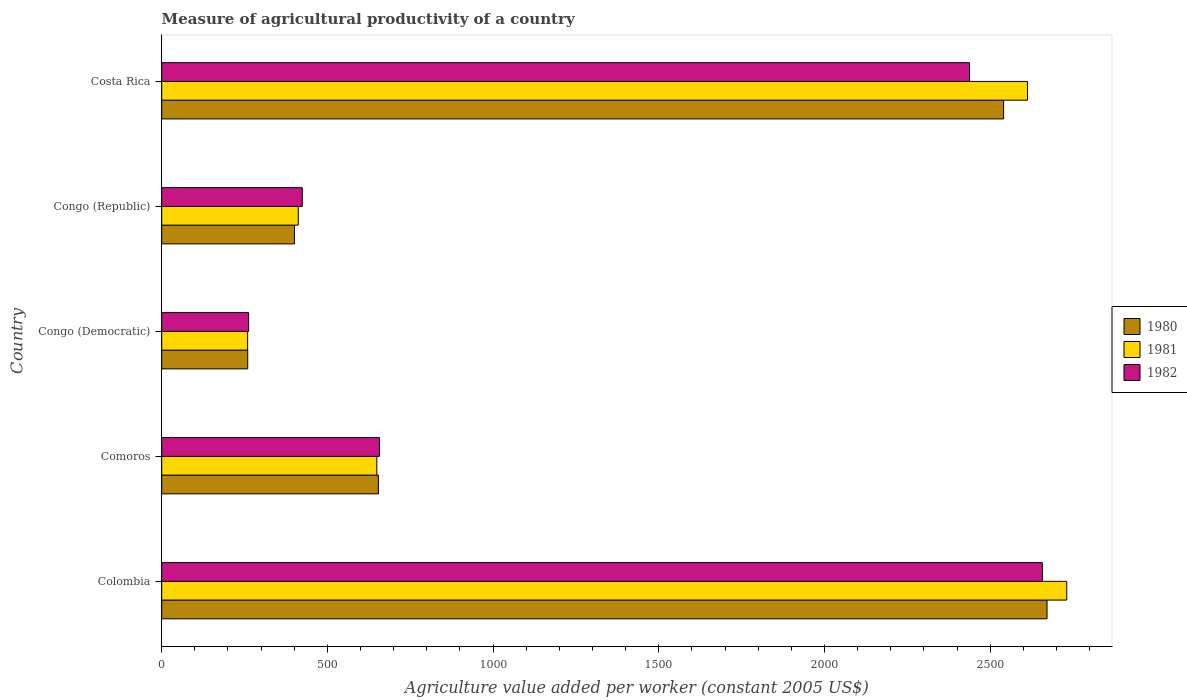How many different coloured bars are there?
Ensure brevity in your answer.  3. Are the number of bars per tick equal to the number of legend labels?
Offer a terse response. Yes. Are the number of bars on each tick of the Y-axis equal?
Your response must be concise. Yes. How many bars are there on the 1st tick from the top?
Your answer should be compact. 3. What is the label of the 2nd group of bars from the top?
Offer a terse response. Congo (Republic). In how many cases, is the number of bars for a given country not equal to the number of legend labels?
Make the answer very short. 0. What is the measure of agricultural productivity in 1982 in Comoros?
Provide a succinct answer. 657.19. Across all countries, what is the maximum measure of agricultural productivity in 1982?
Give a very brief answer. 2657.56. Across all countries, what is the minimum measure of agricultural productivity in 1981?
Make the answer very short. 259.31. In which country was the measure of agricultural productivity in 1980 maximum?
Provide a short and direct response. Colombia. In which country was the measure of agricultural productivity in 1982 minimum?
Keep it short and to the point. Congo (Democratic). What is the total measure of agricultural productivity in 1981 in the graph?
Offer a very short reply. 6664.21. What is the difference between the measure of agricultural productivity in 1982 in Congo (Democratic) and that in Costa Rica?
Ensure brevity in your answer.  -2175.37. What is the difference between the measure of agricultural productivity in 1981 in Comoros and the measure of agricultural productivity in 1980 in Congo (Republic)?
Offer a terse response. 248.5. What is the average measure of agricultural productivity in 1982 per country?
Offer a terse response. 1287.78. What is the difference between the measure of agricultural productivity in 1982 and measure of agricultural productivity in 1981 in Colombia?
Give a very brief answer. -73.46. What is the ratio of the measure of agricultural productivity in 1980 in Congo (Republic) to that in Costa Rica?
Ensure brevity in your answer.  0.16. Is the measure of agricultural productivity in 1980 in Congo (Democratic) less than that in Costa Rica?
Give a very brief answer. Yes. What is the difference between the highest and the second highest measure of agricultural productivity in 1982?
Offer a very short reply. 219.89. What is the difference between the highest and the lowest measure of agricultural productivity in 1981?
Make the answer very short. 2471.71. What does the 2nd bar from the bottom in Comoros represents?
Provide a short and direct response. 1981. Is it the case that in every country, the sum of the measure of agricultural productivity in 1981 and measure of agricultural productivity in 1982 is greater than the measure of agricultural productivity in 1980?
Your answer should be compact. Yes. What is the difference between two consecutive major ticks on the X-axis?
Your answer should be compact. 500. Are the values on the major ticks of X-axis written in scientific E-notation?
Your answer should be very brief. No. How are the legend labels stacked?
Keep it short and to the point. Vertical. What is the title of the graph?
Offer a terse response. Measure of agricultural productivity of a country. Does "1963" appear as one of the legend labels in the graph?
Your answer should be compact. No. What is the label or title of the X-axis?
Your answer should be compact. Agriculture value added per worker (constant 2005 US$). What is the Agriculture value added per worker (constant 2005 US$) in 1980 in Colombia?
Make the answer very short. 2671.6. What is the Agriculture value added per worker (constant 2005 US$) of 1981 in Colombia?
Provide a short and direct response. 2731.02. What is the Agriculture value added per worker (constant 2005 US$) of 1982 in Colombia?
Offer a very short reply. 2657.56. What is the Agriculture value added per worker (constant 2005 US$) in 1980 in Comoros?
Your answer should be very brief. 653.86. What is the Agriculture value added per worker (constant 2005 US$) of 1981 in Comoros?
Keep it short and to the point. 649.11. What is the Agriculture value added per worker (constant 2005 US$) of 1982 in Comoros?
Provide a succinct answer. 657.19. What is the Agriculture value added per worker (constant 2005 US$) of 1980 in Congo (Democratic)?
Your answer should be compact. 259.6. What is the Agriculture value added per worker (constant 2005 US$) in 1981 in Congo (Democratic)?
Ensure brevity in your answer.  259.31. What is the Agriculture value added per worker (constant 2005 US$) of 1982 in Congo (Democratic)?
Provide a short and direct response. 262.3. What is the Agriculture value added per worker (constant 2005 US$) in 1980 in Congo (Republic)?
Make the answer very short. 400.61. What is the Agriculture value added per worker (constant 2005 US$) in 1981 in Congo (Republic)?
Your answer should be very brief. 412. What is the Agriculture value added per worker (constant 2005 US$) of 1982 in Congo (Republic)?
Offer a very short reply. 424.18. What is the Agriculture value added per worker (constant 2005 US$) of 1980 in Costa Rica?
Offer a very short reply. 2540.48. What is the Agriculture value added per worker (constant 2005 US$) of 1981 in Costa Rica?
Give a very brief answer. 2612.77. What is the Agriculture value added per worker (constant 2005 US$) in 1982 in Costa Rica?
Your response must be concise. 2437.67. Across all countries, what is the maximum Agriculture value added per worker (constant 2005 US$) in 1980?
Give a very brief answer. 2671.6. Across all countries, what is the maximum Agriculture value added per worker (constant 2005 US$) in 1981?
Ensure brevity in your answer.  2731.02. Across all countries, what is the maximum Agriculture value added per worker (constant 2005 US$) of 1982?
Make the answer very short. 2657.56. Across all countries, what is the minimum Agriculture value added per worker (constant 2005 US$) in 1980?
Your response must be concise. 259.6. Across all countries, what is the minimum Agriculture value added per worker (constant 2005 US$) in 1981?
Keep it short and to the point. 259.31. Across all countries, what is the minimum Agriculture value added per worker (constant 2005 US$) in 1982?
Ensure brevity in your answer.  262.3. What is the total Agriculture value added per worker (constant 2005 US$) in 1980 in the graph?
Ensure brevity in your answer.  6526.15. What is the total Agriculture value added per worker (constant 2005 US$) of 1981 in the graph?
Offer a very short reply. 6664.21. What is the total Agriculture value added per worker (constant 2005 US$) of 1982 in the graph?
Your answer should be compact. 6438.9. What is the difference between the Agriculture value added per worker (constant 2005 US$) in 1980 in Colombia and that in Comoros?
Offer a very short reply. 2017.73. What is the difference between the Agriculture value added per worker (constant 2005 US$) in 1981 in Colombia and that in Comoros?
Ensure brevity in your answer.  2081.9. What is the difference between the Agriculture value added per worker (constant 2005 US$) in 1982 in Colombia and that in Comoros?
Ensure brevity in your answer.  2000.38. What is the difference between the Agriculture value added per worker (constant 2005 US$) in 1980 in Colombia and that in Congo (Democratic)?
Make the answer very short. 2412. What is the difference between the Agriculture value added per worker (constant 2005 US$) of 1981 in Colombia and that in Congo (Democratic)?
Your answer should be compact. 2471.71. What is the difference between the Agriculture value added per worker (constant 2005 US$) of 1982 in Colombia and that in Congo (Democratic)?
Make the answer very short. 2395.26. What is the difference between the Agriculture value added per worker (constant 2005 US$) in 1980 in Colombia and that in Congo (Republic)?
Your answer should be very brief. 2270.98. What is the difference between the Agriculture value added per worker (constant 2005 US$) in 1981 in Colombia and that in Congo (Republic)?
Provide a short and direct response. 2319.02. What is the difference between the Agriculture value added per worker (constant 2005 US$) in 1982 in Colombia and that in Congo (Republic)?
Make the answer very short. 2233.39. What is the difference between the Agriculture value added per worker (constant 2005 US$) of 1980 in Colombia and that in Costa Rica?
Give a very brief answer. 131.12. What is the difference between the Agriculture value added per worker (constant 2005 US$) in 1981 in Colombia and that in Costa Rica?
Provide a short and direct response. 118.25. What is the difference between the Agriculture value added per worker (constant 2005 US$) of 1982 in Colombia and that in Costa Rica?
Provide a short and direct response. 219.89. What is the difference between the Agriculture value added per worker (constant 2005 US$) of 1980 in Comoros and that in Congo (Democratic)?
Offer a very short reply. 394.26. What is the difference between the Agriculture value added per worker (constant 2005 US$) of 1981 in Comoros and that in Congo (Democratic)?
Offer a terse response. 389.81. What is the difference between the Agriculture value added per worker (constant 2005 US$) in 1982 in Comoros and that in Congo (Democratic)?
Give a very brief answer. 394.89. What is the difference between the Agriculture value added per worker (constant 2005 US$) of 1980 in Comoros and that in Congo (Republic)?
Your answer should be compact. 253.25. What is the difference between the Agriculture value added per worker (constant 2005 US$) in 1981 in Comoros and that in Congo (Republic)?
Ensure brevity in your answer.  237.12. What is the difference between the Agriculture value added per worker (constant 2005 US$) of 1982 in Comoros and that in Congo (Republic)?
Your answer should be compact. 233.01. What is the difference between the Agriculture value added per worker (constant 2005 US$) in 1980 in Comoros and that in Costa Rica?
Provide a succinct answer. -1886.62. What is the difference between the Agriculture value added per worker (constant 2005 US$) of 1981 in Comoros and that in Costa Rica?
Provide a short and direct response. -1963.65. What is the difference between the Agriculture value added per worker (constant 2005 US$) in 1982 in Comoros and that in Costa Rica?
Your answer should be compact. -1780.48. What is the difference between the Agriculture value added per worker (constant 2005 US$) of 1980 in Congo (Democratic) and that in Congo (Republic)?
Make the answer very short. -141.01. What is the difference between the Agriculture value added per worker (constant 2005 US$) of 1981 in Congo (Democratic) and that in Congo (Republic)?
Provide a succinct answer. -152.69. What is the difference between the Agriculture value added per worker (constant 2005 US$) of 1982 in Congo (Democratic) and that in Congo (Republic)?
Provide a short and direct response. -161.87. What is the difference between the Agriculture value added per worker (constant 2005 US$) of 1980 in Congo (Democratic) and that in Costa Rica?
Ensure brevity in your answer.  -2280.88. What is the difference between the Agriculture value added per worker (constant 2005 US$) of 1981 in Congo (Democratic) and that in Costa Rica?
Provide a succinct answer. -2353.46. What is the difference between the Agriculture value added per worker (constant 2005 US$) in 1982 in Congo (Democratic) and that in Costa Rica?
Your answer should be compact. -2175.37. What is the difference between the Agriculture value added per worker (constant 2005 US$) of 1980 in Congo (Republic) and that in Costa Rica?
Provide a short and direct response. -2139.87. What is the difference between the Agriculture value added per worker (constant 2005 US$) of 1981 in Congo (Republic) and that in Costa Rica?
Your answer should be compact. -2200.77. What is the difference between the Agriculture value added per worker (constant 2005 US$) of 1982 in Congo (Republic) and that in Costa Rica?
Offer a very short reply. -2013.5. What is the difference between the Agriculture value added per worker (constant 2005 US$) of 1980 in Colombia and the Agriculture value added per worker (constant 2005 US$) of 1981 in Comoros?
Ensure brevity in your answer.  2022.48. What is the difference between the Agriculture value added per worker (constant 2005 US$) in 1980 in Colombia and the Agriculture value added per worker (constant 2005 US$) in 1982 in Comoros?
Provide a short and direct response. 2014.41. What is the difference between the Agriculture value added per worker (constant 2005 US$) of 1981 in Colombia and the Agriculture value added per worker (constant 2005 US$) of 1982 in Comoros?
Give a very brief answer. 2073.83. What is the difference between the Agriculture value added per worker (constant 2005 US$) in 1980 in Colombia and the Agriculture value added per worker (constant 2005 US$) in 1981 in Congo (Democratic)?
Provide a succinct answer. 2412.29. What is the difference between the Agriculture value added per worker (constant 2005 US$) in 1980 in Colombia and the Agriculture value added per worker (constant 2005 US$) in 1982 in Congo (Democratic)?
Ensure brevity in your answer.  2409.29. What is the difference between the Agriculture value added per worker (constant 2005 US$) in 1981 in Colombia and the Agriculture value added per worker (constant 2005 US$) in 1982 in Congo (Democratic)?
Provide a short and direct response. 2468.72. What is the difference between the Agriculture value added per worker (constant 2005 US$) of 1980 in Colombia and the Agriculture value added per worker (constant 2005 US$) of 1981 in Congo (Republic)?
Provide a short and direct response. 2259.6. What is the difference between the Agriculture value added per worker (constant 2005 US$) in 1980 in Colombia and the Agriculture value added per worker (constant 2005 US$) in 1982 in Congo (Republic)?
Keep it short and to the point. 2247.42. What is the difference between the Agriculture value added per worker (constant 2005 US$) in 1981 in Colombia and the Agriculture value added per worker (constant 2005 US$) in 1982 in Congo (Republic)?
Offer a very short reply. 2306.84. What is the difference between the Agriculture value added per worker (constant 2005 US$) in 1980 in Colombia and the Agriculture value added per worker (constant 2005 US$) in 1981 in Costa Rica?
Offer a terse response. 58.83. What is the difference between the Agriculture value added per worker (constant 2005 US$) of 1980 in Colombia and the Agriculture value added per worker (constant 2005 US$) of 1982 in Costa Rica?
Your answer should be compact. 233.92. What is the difference between the Agriculture value added per worker (constant 2005 US$) in 1981 in Colombia and the Agriculture value added per worker (constant 2005 US$) in 1982 in Costa Rica?
Offer a very short reply. 293.35. What is the difference between the Agriculture value added per worker (constant 2005 US$) in 1980 in Comoros and the Agriculture value added per worker (constant 2005 US$) in 1981 in Congo (Democratic)?
Keep it short and to the point. 394.55. What is the difference between the Agriculture value added per worker (constant 2005 US$) in 1980 in Comoros and the Agriculture value added per worker (constant 2005 US$) in 1982 in Congo (Democratic)?
Your answer should be very brief. 391.56. What is the difference between the Agriculture value added per worker (constant 2005 US$) of 1981 in Comoros and the Agriculture value added per worker (constant 2005 US$) of 1982 in Congo (Democratic)?
Ensure brevity in your answer.  386.81. What is the difference between the Agriculture value added per worker (constant 2005 US$) in 1980 in Comoros and the Agriculture value added per worker (constant 2005 US$) in 1981 in Congo (Republic)?
Keep it short and to the point. 241.86. What is the difference between the Agriculture value added per worker (constant 2005 US$) in 1980 in Comoros and the Agriculture value added per worker (constant 2005 US$) in 1982 in Congo (Republic)?
Your answer should be compact. 229.69. What is the difference between the Agriculture value added per worker (constant 2005 US$) in 1981 in Comoros and the Agriculture value added per worker (constant 2005 US$) in 1982 in Congo (Republic)?
Provide a succinct answer. 224.94. What is the difference between the Agriculture value added per worker (constant 2005 US$) in 1980 in Comoros and the Agriculture value added per worker (constant 2005 US$) in 1981 in Costa Rica?
Your answer should be compact. -1958.91. What is the difference between the Agriculture value added per worker (constant 2005 US$) of 1980 in Comoros and the Agriculture value added per worker (constant 2005 US$) of 1982 in Costa Rica?
Your response must be concise. -1783.81. What is the difference between the Agriculture value added per worker (constant 2005 US$) of 1981 in Comoros and the Agriculture value added per worker (constant 2005 US$) of 1982 in Costa Rica?
Make the answer very short. -1788.56. What is the difference between the Agriculture value added per worker (constant 2005 US$) in 1980 in Congo (Democratic) and the Agriculture value added per worker (constant 2005 US$) in 1981 in Congo (Republic)?
Keep it short and to the point. -152.4. What is the difference between the Agriculture value added per worker (constant 2005 US$) of 1980 in Congo (Democratic) and the Agriculture value added per worker (constant 2005 US$) of 1982 in Congo (Republic)?
Offer a terse response. -164.58. What is the difference between the Agriculture value added per worker (constant 2005 US$) of 1981 in Congo (Democratic) and the Agriculture value added per worker (constant 2005 US$) of 1982 in Congo (Republic)?
Offer a very short reply. -164.87. What is the difference between the Agriculture value added per worker (constant 2005 US$) of 1980 in Congo (Democratic) and the Agriculture value added per worker (constant 2005 US$) of 1981 in Costa Rica?
Keep it short and to the point. -2353.17. What is the difference between the Agriculture value added per worker (constant 2005 US$) of 1980 in Congo (Democratic) and the Agriculture value added per worker (constant 2005 US$) of 1982 in Costa Rica?
Your response must be concise. -2178.07. What is the difference between the Agriculture value added per worker (constant 2005 US$) in 1981 in Congo (Democratic) and the Agriculture value added per worker (constant 2005 US$) in 1982 in Costa Rica?
Your answer should be compact. -2178.36. What is the difference between the Agriculture value added per worker (constant 2005 US$) in 1980 in Congo (Republic) and the Agriculture value added per worker (constant 2005 US$) in 1981 in Costa Rica?
Keep it short and to the point. -2212.16. What is the difference between the Agriculture value added per worker (constant 2005 US$) of 1980 in Congo (Republic) and the Agriculture value added per worker (constant 2005 US$) of 1982 in Costa Rica?
Provide a succinct answer. -2037.06. What is the difference between the Agriculture value added per worker (constant 2005 US$) of 1981 in Congo (Republic) and the Agriculture value added per worker (constant 2005 US$) of 1982 in Costa Rica?
Provide a succinct answer. -2025.67. What is the average Agriculture value added per worker (constant 2005 US$) in 1980 per country?
Provide a succinct answer. 1305.23. What is the average Agriculture value added per worker (constant 2005 US$) in 1981 per country?
Your response must be concise. 1332.84. What is the average Agriculture value added per worker (constant 2005 US$) of 1982 per country?
Offer a very short reply. 1287.78. What is the difference between the Agriculture value added per worker (constant 2005 US$) of 1980 and Agriculture value added per worker (constant 2005 US$) of 1981 in Colombia?
Offer a very short reply. -59.42. What is the difference between the Agriculture value added per worker (constant 2005 US$) in 1980 and Agriculture value added per worker (constant 2005 US$) in 1982 in Colombia?
Keep it short and to the point. 14.03. What is the difference between the Agriculture value added per worker (constant 2005 US$) in 1981 and Agriculture value added per worker (constant 2005 US$) in 1982 in Colombia?
Offer a very short reply. 73.46. What is the difference between the Agriculture value added per worker (constant 2005 US$) in 1980 and Agriculture value added per worker (constant 2005 US$) in 1981 in Comoros?
Offer a terse response. 4.75. What is the difference between the Agriculture value added per worker (constant 2005 US$) of 1980 and Agriculture value added per worker (constant 2005 US$) of 1982 in Comoros?
Offer a terse response. -3.33. What is the difference between the Agriculture value added per worker (constant 2005 US$) of 1981 and Agriculture value added per worker (constant 2005 US$) of 1982 in Comoros?
Your answer should be very brief. -8.07. What is the difference between the Agriculture value added per worker (constant 2005 US$) of 1980 and Agriculture value added per worker (constant 2005 US$) of 1981 in Congo (Democratic)?
Your response must be concise. 0.29. What is the difference between the Agriculture value added per worker (constant 2005 US$) in 1980 and Agriculture value added per worker (constant 2005 US$) in 1982 in Congo (Democratic)?
Provide a succinct answer. -2.7. What is the difference between the Agriculture value added per worker (constant 2005 US$) of 1981 and Agriculture value added per worker (constant 2005 US$) of 1982 in Congo (Democratic)?
Give a very brief answer. -2.99. What is the difference between the Agriculture value added per worker (constant 2005 US$) of 1980 and Agriculture value added per worker (constant 2005 US$) of 1981 in Congo (Republic)?
Ensure brevity in your answer.  -11.38. What is the difference between the Agriculture value added per worker (constant 2005 US$) of 1980 and Agriculture value added per worker (constant 2005 US$) of 1982 in Congo (Republic)?
Offer a terse response. -23.56. What is the difference between the Agriculture value added per worker (constant 2005 US$) of 1981 and Agriculture value added per worker (constant 2005 US$) of 1982 in Congo (Republic)?
Give a very brief answer. -12.18. What is the difference between the Agriculture value added per worker (constant 2005 US$) in 1980 and Agriculture value added per worker (constant 2005 US$) in 1981 in Costa Rica?
Offer a very short reply. -72.29. What is the difference between the Agriculture value added per worker (constant 2005 US$) of 1980 and Agriculture value added per worker (constant 2005 US$) of 1982 in Costa Rica?
Your response must be concise. 102.81. What is the difference between the Agriculture value added per worker (constant 2005 US$) of 1981 and Agriculture value added per worker (constant 2005 US$) of 1982 in Costa Rica?
Keep it short and to the point. 175.1. What is the ratio of the Agriculture value added per worker (constant 2005 US$) in 1980 in Colombia to that in Comoros?
Your response must be concise. 4.09. What is the ratio of the Agriculture value added per worker (constant 2005 US$) in 1981 in Colombia to that in Comoros?
Keep it short and to the point. 4.21. What is the ratio of the Agriculture value added per worker (constant 2005 US$) in 1982 in Colombia to that in Comoros?
Provide a succinct answer. 4.04. What is the ratio of the Agriculture value added per worker (constant 2005 US$) in 1980 in Colombia to that in Congo (Democratic)?
Give a very brief answer. 10.29. What is the ratio of the Agriculture value added per worker (constant 2005 US$) of 1981 in Colombia to that in Congo (Democratic)?
Keep it short and to the point. 10.53. What is the ratio of the Agriculture value added per worker (constant 2005 US$) in 1982 in Colombia to that in Congo (Democratic)?
Offer a terse response. 10.13. What is the ratio of the Agriculture value added per worker (constant 2005 US$) in 1980 in Colombia to that in Congo (Republic)?
Your answer should be very brief. 6.67. What is the ratio of the Agriculture value added per worker (constant 2005 US$) of 1981 in Colombia to that in Congo (Republic)?
Your answer should be compact. 6.63. What is the ratio of the Agriculture value added per worker (constant 2005 US$) of 1982 in Colombia to that in Congo (Republic)?
Your answer should be compact. 6.27. What is the ratio of the Agriculture value added per worker (constant 2005 US$) of 1980 in Colombia to that in Costa Rica?
Keep it short and to the point. 1.05. What is the ratio of the Agriculture value added per worker (constant 2005 US$) of 1981 in Colombia to that in Costa Rica?
Your response must be concise. 1.05. What is the ratio of the Agriculture value added per worker (constant 2005 US$) of 1982 in Colombia to that in Costa Rica?
Provide a short and direct response. 1.09. What is the ratio of the Agriculture value added per worker (constant 2005 US$) in 1980 in Comoros to that in Congo (Democratic)?
Your answer should be very brief. 2.52. What is the ratio of the Agriculture value added per worker (constant 2005 US$) in 1981 in Comoros to that in Congo (Democratic)?
Keep it short and to the point. 2.5. What is the ratio of the Agriculture value added per worker (constant 2005 US$) in 1982 in Comoros to that in Congo (Democratic)?
Offer a very short reply. 2.51. What is the ratio of the Agriculture value added per worker (constant 2005 US$) in 1980 in Comoros to that in Congo (Republic)?
Keep it short and to the point. 1.63. What is the ratio of the Agriculture value added per worker (constant 2005 US$) of 1981 in Comoros to that in Congo (Republic)?
Provide a succinct answer. 1.58. What is the ratio of the Agriculture value added per worker (constant 2005 US$) of 1982 in Comoros to that in Congo (Republic)?
Keep it short and to the point. 1.55. What is the ratio of the Agriculture value added per worker (constant 2005 US$) of 1980 in Comoros to that in Costa Rica?
Provide a short and direct response. 0.26. What is the ratio of the Agriculture value added per worker (constant 2005 US$) of 1981 in Comoros to that in Costa Rica?
Provide a succinct answer. 0.25. What is the ratio of the Agriculture value added per worker (constant 2005 US$) in 1982 in Comoros to that in Costa Rica?
Offer a terse response. 0.27. What is the ratio of the Agriculture value added per worker (constant 2005 US$) of 1980 in Congo (Democratic) to that in Congo (Republic)?
Provide a succinct answer. 0.65. What is the ratio of the Agriculture value added per worker (constant 2005 US$) in 1981 in Congo (Democratic) to that in Congo (Republic)?
Offer a very short reply. 0.63. What is the ratio of the Agriculture value added per worker (constant 2005 US$) of 1982 in Congo (Democratic) to that in Congo (Republic)?
Provide a succinct answer. 0.62. What is the ratio of the Agriculture value added per worker (constant 2005 US$) of 1980 in Congo (Democratic) to that in Costa Rica?
Make the answer very short. 0.1. What is the ratio of the Agriculture value added per worker (constant 2005 US$) in 1981 in Congo (Democratic) to that in Costa Rica?
Your answer should be very brief. 0.1. What is the ratio of the Agriculture value added per worker (constant 2005 US$) in 1982 in Congo (Democratic) to that in Costa Rica?
Give a very brief answer. 0.11. What is the ratio of the Agriculture value added per worker (constant 2005 US$) of 1980 in Congo (Republic) to that in Costa Rica?
Provide a succinct answer. 0.16. What is the ratio of the Agriculture value added per worker (constant 2005 US$) in 1981 in Congo (Republic) to that in Costa Rica?
Ensure brevity in your answer.  0.16. What is the ratio of the Agriculture value added per worker (constant 2005 US$) in 1982 in Congo (Republic) to that in Costa Rica?
Your answer should be very brief. 0.17. What is the difference between the highest and the second highest Agriculture value added per worker (constant 2005 US$) in 1980?
Give a very brief answer. 131.12. What is the difference between the highest and the second highest Agriculture value added per worker (constant 2005 US$) in 1981?
Provide a short and direct response. 118.25. What is the difference between the highest and the second highest Agriculture value added per worker (constant 2005 US$) in 1982?
Ensure brevity in your answer.  219.89. What is the difference between the highest and the lowest Agriculture value added per worker (constant 2005 US$) of 1980?
Offer a terse response. 2412. What is the difference between the highest and the lowest Agriculture value added per worker (constant 2005 US$) of 1981?
Make the answer very short. 2471.71. What is the difference between the highest and the lowest Agriculture value added per worker (constant 2005 US$) of 1982?
Your answer should be very brief. 2395.26. 